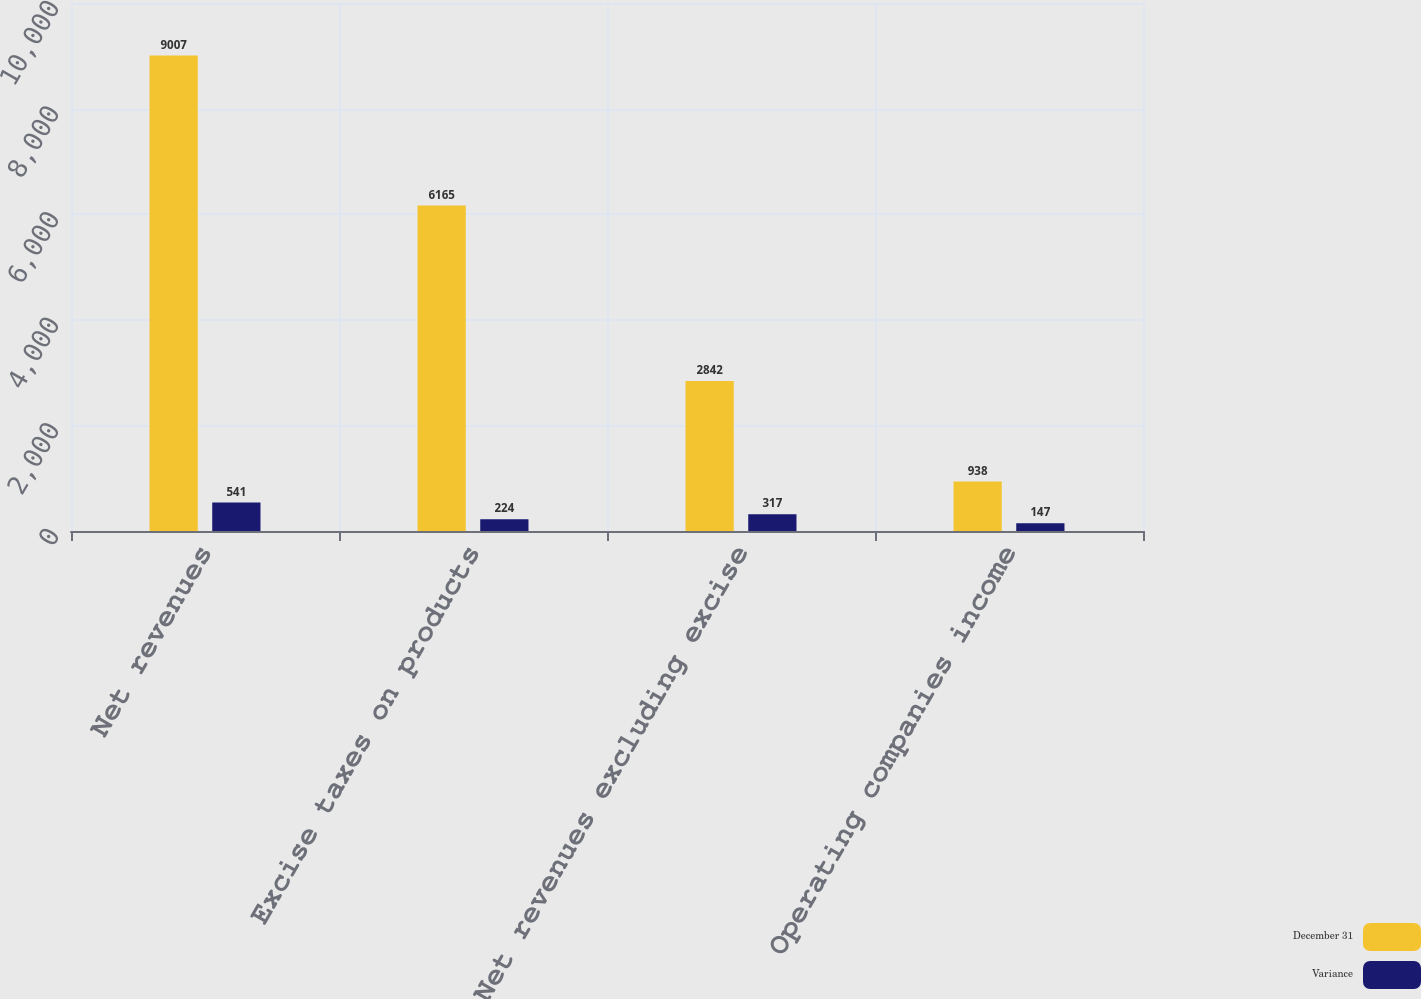Convert chart. <chart><loc_0><loc_0><loc_500><loc_500><stacked_bar_chart><ecel><fcel>Net revenues<fcel>Excise taxes on products<fcel>Net revenues excluding excise<fcel>Operating companies income<nl><fcel>December 31<fcel>9007<fcel>6165<fcel>2842<fcel>938<nl><fcel>Variance<fcel>541<fcel>224<fcel>317<fcel>147<nl></chart> 